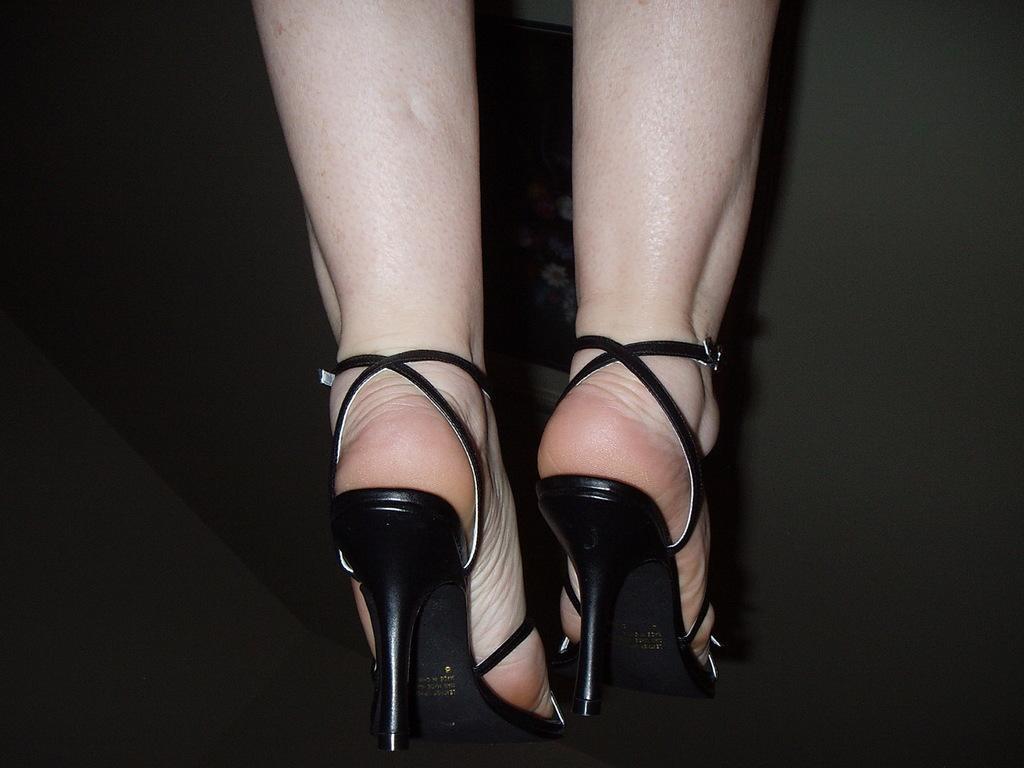Can you describe this image briefly? This picture consists of person leg who is wearing heels, background is dark color. 